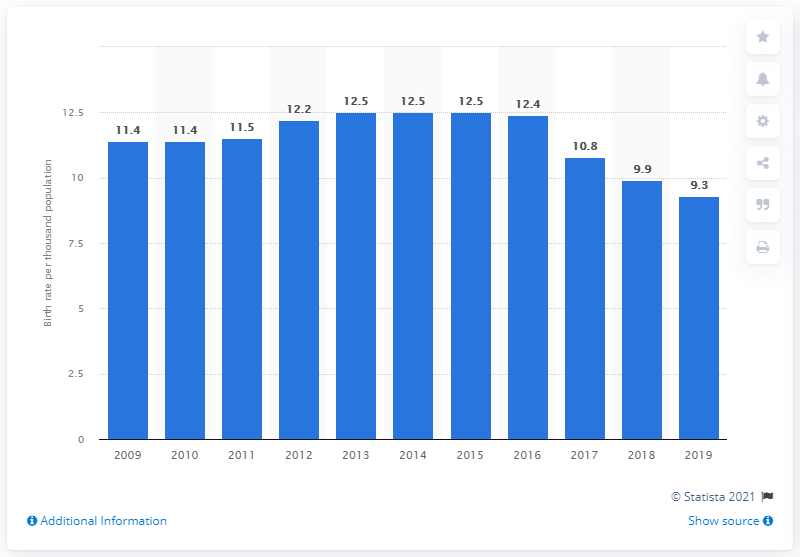Outline some significant characteristics in this image. The crude birth rate in Belarus in 2019 was 9.3. 